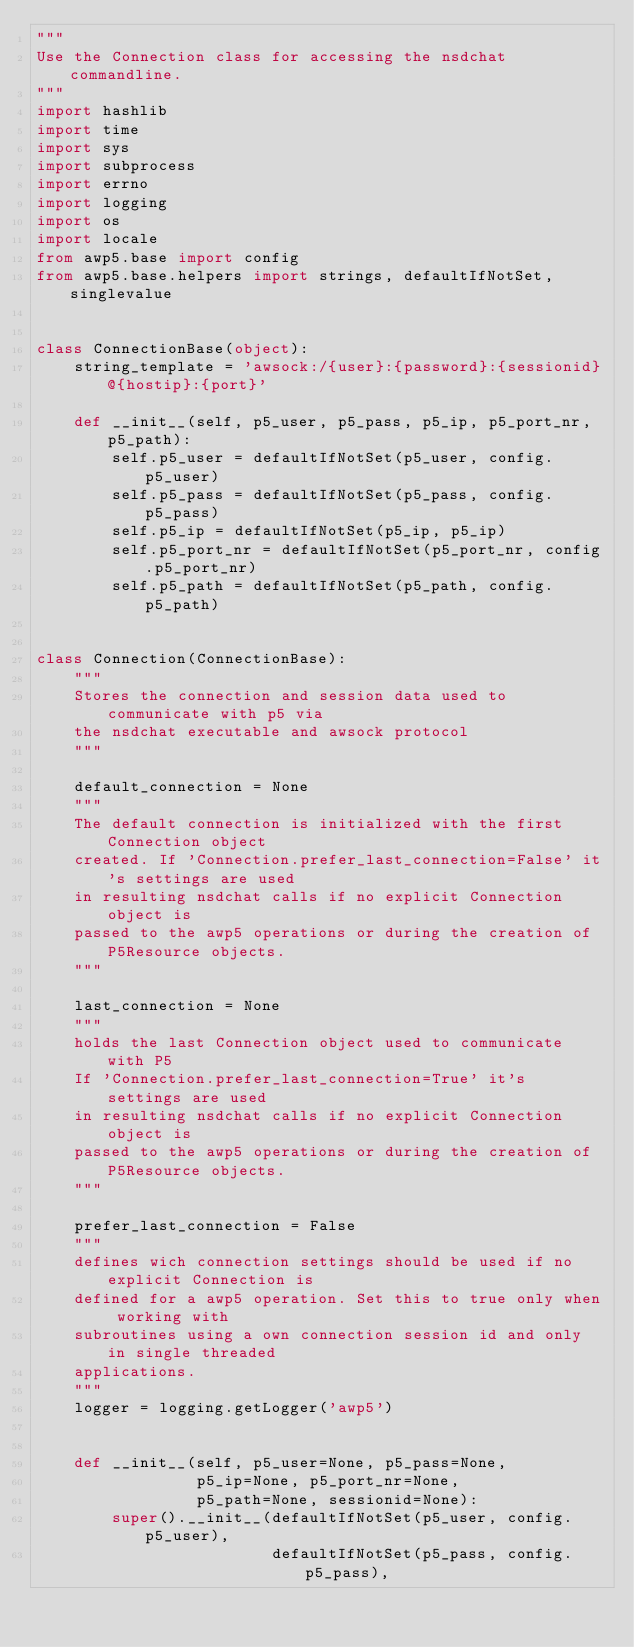Convert code to text. <code><loc_0><loc_0><loc_500><loc_500><_Python_>"""
Use the Connection class for accessing the nsdchat commandline.
"""
import hashlib
import time
import sys
import subprocess
import errno
import logging
import os
import locale
from awp5.base import config
from awp5.base.helpers import strings, defaultIfNotSet, singlevalue


class ConnectionBase(object):
    string_template = 'awsock:/{user}:{password}:{sessionid}@{hostip}:{port}'

    def __init__(self, p5_user, p5_pass, p5_ip, p5_port_nr, p5_path):
        self.p5_user = defaultIfNotSet(p5_user, config.p5_user)
        self.p5_pass = defaultIfNotSet(p5_pass, config.p5_pass)
        self.p5_ip = defaultIfNotSet(p5_ip, p5_ip)
        self.p5_port_nr = defaultIfNotSet(p5_port_nr, config.p5_port_nr)
        self.p5_path = defaultIfNotSet(p5_path, config.p5_path)


class Connection(ConnectionBase):
    """
    Stores the connection and session data used to communicate with p5 via
    the nsdchat executable and awsock protocol
    """
    
    default_connection = None
    """
    The default connection is initialized with the first Connection object
    created. If 'Connection.prefer_last_connection=False' it's settings are used
    in resulting nsdchat calls if no explicit Connection object is
    passed to the awp5 operations or during the creation of P5Resource objects.
    """
    
    last_connection = None
    """
    holds the last Connection object used to communicate with P5
    If 'Connection.prefer_last_connection=True' it's settings are used
    in resulting nsdchat calls if no explicit Connection object is
    passed to the awp5 operations or during the creation of P5Resource objects.
    """
    
    prefer_last_connection = False
    """
    defines wich connection settings should be used if no explicit Connection is
    defined for a awp5 operation. Set this to true only when working with
    subroutines using a own connection session id and only in single threaded
    applications.
    """
    logger = logging.getLogger('awp5')
    

    def __init__(self, p5_user=None, p5_pass=None,
                 p5_ip=None, p5_port_nr=None,
                 p5_path=None, sessionid=None):
        super().__init__(defaultIfNotSet(p5_user, config.p5_user),
                         defaultIfNotSet(p5_pass, config.p5_pass),</code> 